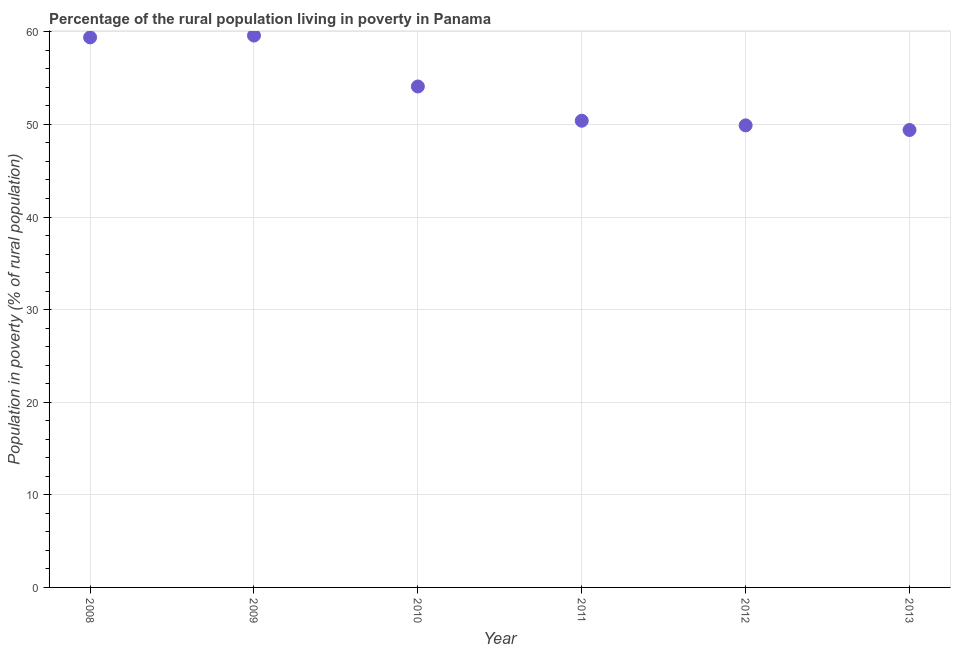What is the percentage of rural population living below poverty line in 2013?
Your answer should be compact. 49.4. Across all years, what is the maximum percentage of rural population living below poverty line?
Your answer should be very brief. 59.6. Across all years, what is the minimum percentage of rural population living below poverty line?
Offer a very short reply. 49.4. In which year was the percentage of rural population living below poverty line minimum?
Give a very brief answer. 2013. What is the sum of the percentage of rural population living below poverty line?
Your response must be concise. 322.8. What is the difference between the percentage of rural population living below poverty line in 2009 and 2011?
Make the answer very short. 9.2. What is the average percentage of rural population living below poverty line per year?
Your response must be concise. 53.8. What is the median percentage of rural population living below poverty line?
Provide a succinct answer. 52.25. Do a majority of the years between 2013 and 2008 (inclusive) have percentage of rural population living below poverty line greater than 28 %?
Provide a succinct answer. Yes. What is the ratio of the percentage of rural population living below poverty line in 2008 to that in 2011?
Give a very brief answer. 1.18. Is the difference between the percentage of rural population living below poverty line in 2012 and 2013 greater than the difference between any two years?
Make the answer very short. No. What is the difference between the highest and the second highest percentage of rural population living below poverty line?
Your answer should be compact. 0.2. Is the sum of the percentage of rural population living below poverty line in 2008 and 2011 greater than the maximum percentage of rural population living below poverty line across all years?
Make the answer very short. Yes. What is the difference between the highest and the lowest percentage of rural population living below poverty line?
Your answer should be very brief. 10.2. Does the percentage of rural population living below poverty line monotonically increase over the years?
Your answer should be compact. No. How many years are there in the graph?
Keep it short and to the point. 6. Are the values on the major ticks of Y-axis written in scientific E-notation?
Your response must be concise. No. Does the graph contain grids?
Give a very brief answer. Yes. What is the title of the graph?
Your answer should be compact. Percentage of the rural population living in poverty in Panama. What is the label or title of the Y-axis?
Your response must be concise. Population in poverty (% of rural population). What is the Population in poverty (% of rural population) in 2008?
Your answer should be very brief. 59.4. What is the Population in poverty (% of rural population) in 2009?
Give a very brief answer. 59.6. What is the Population in poverty (% of rural population) in 2010?
Offer a very short reply. 54.1. What is the Population in poverty (% of rural population) in 2011?
Provide a succinct answer. 50.4. What is the Population in poverty (% of rural population) in 2012?
Your answer should be very brief. 49.9. What is the Population in poverty (% of rural population) in 2013?
Provide a succinct answer. 49.4. What is the difference between the Population in poverty (% of rural population) in 2008 and 2009?
Provide a short and direct response. -0.2. What is the difference between the Population in poverty (% of rural population) in 2008 and 2010?
Your response must be concise. 5.3. What is the difference between the Population in poverty (% of rural population) in 2008 and 2011?
Ensure brevity in your answer.  9. What is the difference between the Population in poverty (% of rural population) in 2009 and 2013?
Ensure brevity in your answer.  10.2. What is the difference between the Population in poverty (% of rural population) in 2010 and 2011?
Keep it short and to the point. 3.7. What is the difference between the Population in poverty (% of rural population) in 2011 and 2012?
Give a very brief answer. 0.5. What is the difference between the Population in poverty (% of rural population) in 2012 and 2013?
Your response must be concise. 0.5. What is the ratio of the Population in poverty (% of rural population) in 2008 to that in 2010?
Provide a succinct answer. 1.1. What is the ratio of the Population in poverty (% of rural population) in 2008 to that in 2011?
Ensure brevity in your answer.  1.18. What is the ratio of the Population in poverty (% of rural population) in 2008 to that in 2012?
Keep it short and to the point. 1.19. What is the ratio of the Population in poverty (% of rural population) in 2008 to that in 2013?
Keep it short and to the point. 1.2. What is the ratio of the Population in poverty (% of rural population) in 2009 to that in 2010?
Your response must be concise. 1.1. What is the ratio of the Population in poverty (% of rural population) in 2009 to that in 2011?
Make the answer very short. 1.18. What is the ratio of the Population in poverty (% of rural population) in 2009 to that in 2012?
Give a very brief answer. 1.19. What is the ratio of the Population in poverty (% of rural population) in 2009 to that in 2013?
Keep it short and to the point. 1.21. What is the ratio of the Population in poverty (% of rural population) in 2010 to that in 2011?
Give a very brief answer. 1.07. What is the ratio of the Population in poverty (% of rural population) in 2010 to that in 2012?
Your response must be concise. 1.08. What is the ratio of the Population in poverty (% of rural population) in 2010 to that in 2013?
Make the answer very short. 1.09. What is the ratio of the Population in poverty (% of rural population) in 2011 to that in 2013?
Your answer should be compact. 1.02. 